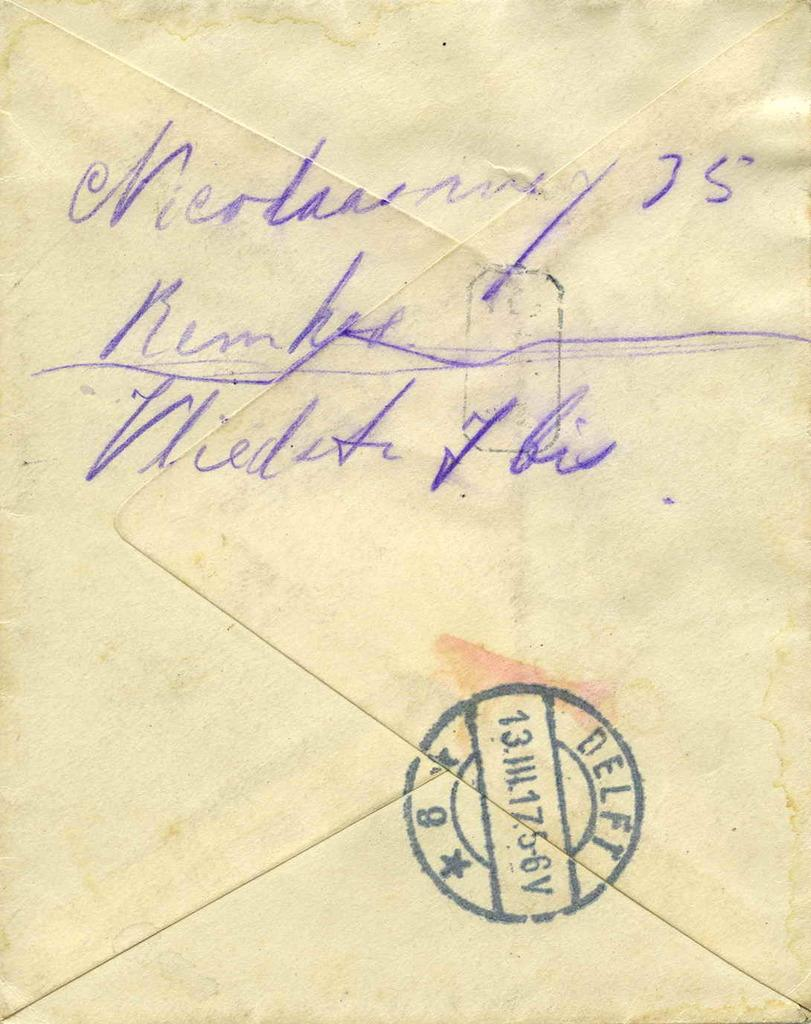<image>
Summarize the visual content of the image. A stamp on the back of an envelope has a number beginning with 13. 